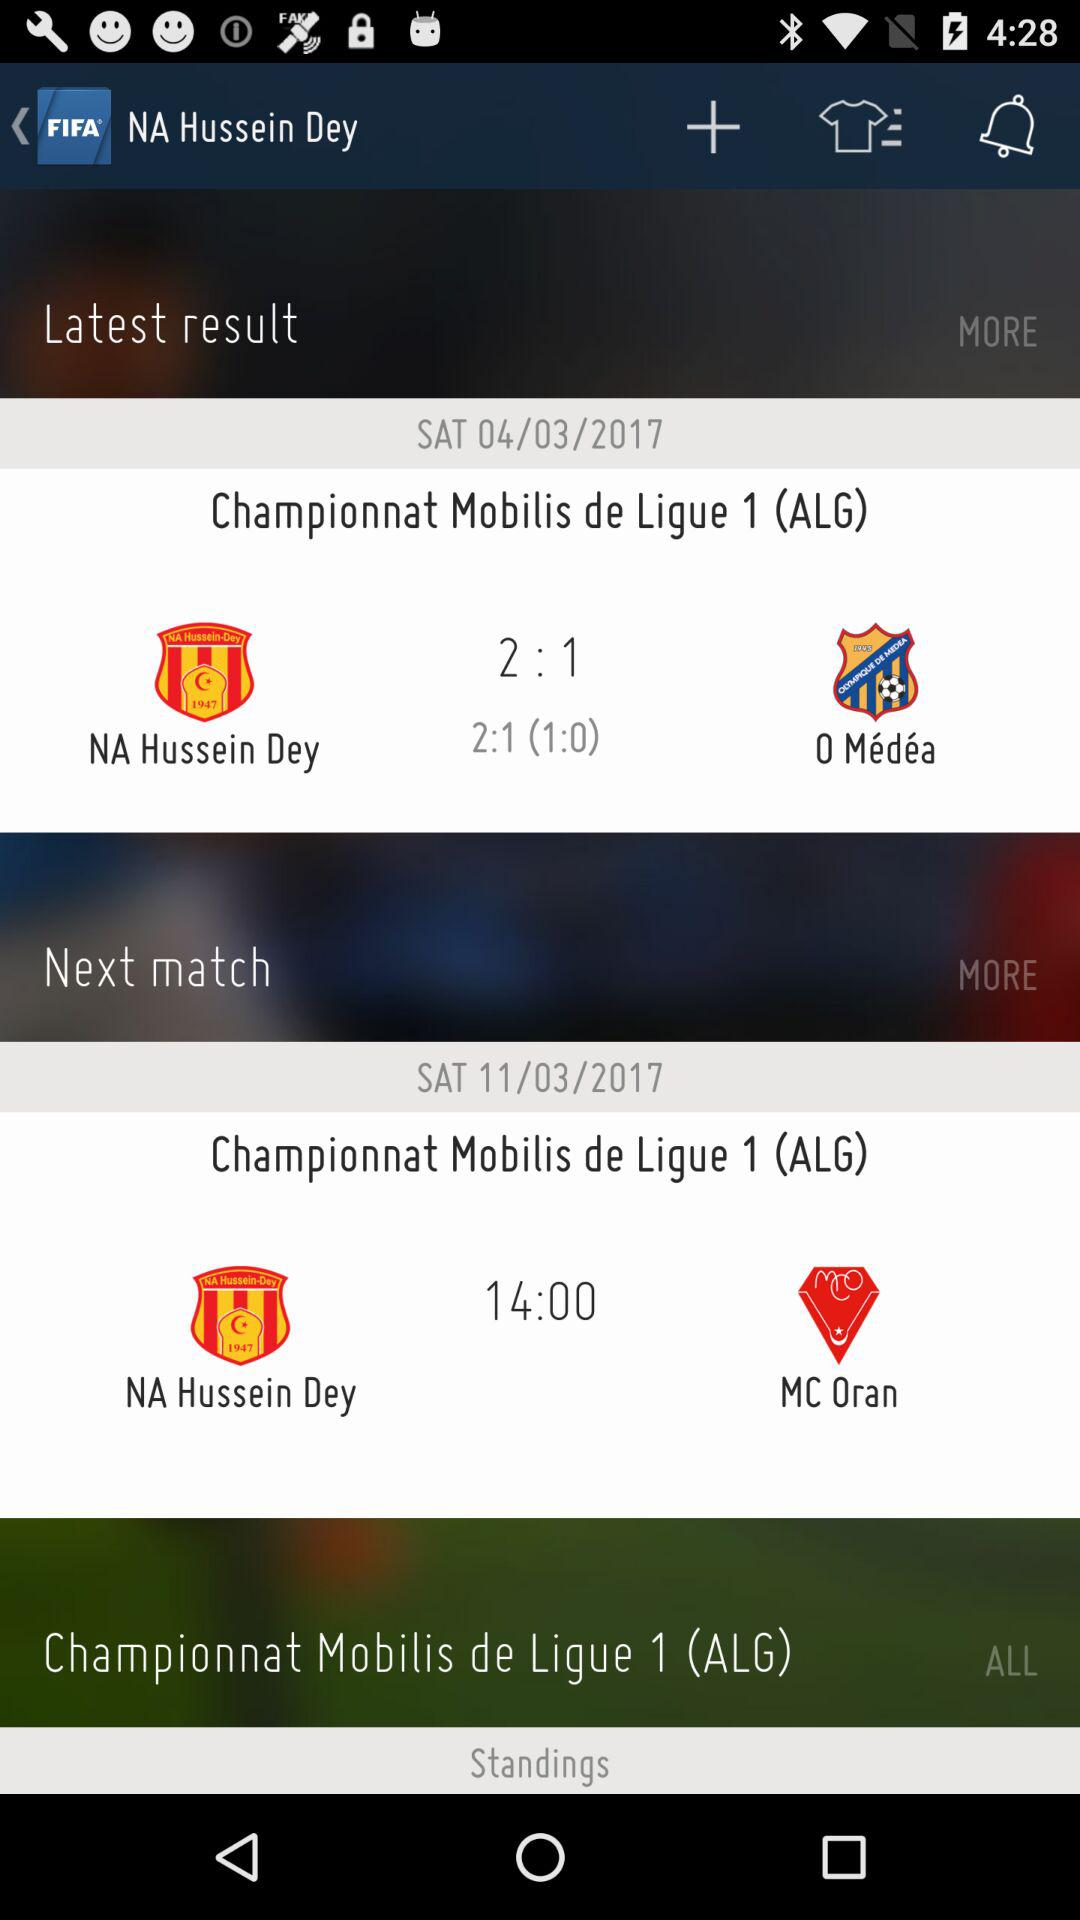What's the number of goals scored by "NA Hussein Dey" in the "Championnat Mobilis de Ligue" on March 4, 2017? The number of goals scored by "NA Hussein Dey" in the "Championnat Mobilis de Ligue" on March 4, 2017 is 2. 